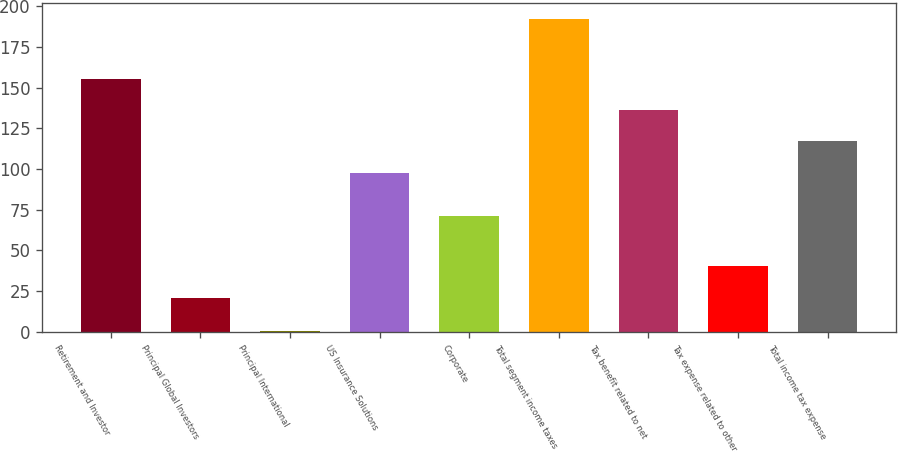Convert chart to OTSL. <chart><loc_0><loc_0><loc_500><loc_500><bar_chart><fcel>Retirement and Investor<fcel>Principal Global Investors<fcel>Principal International<fcel>US Insurance Solutions<fcel>Corporate<fcel>Total segment income taxes<fcel>Tax benefit related to net<fcel>Tax expense related to other<fcel>Total income tax expense<nl><fcel>155.28<fcel>21<fcel>0.5<fcel>97.8<fcel>71.4<fcel>192.1<fcel>136.12<fcel>40.16<fcel>116.96<nl></chart> 